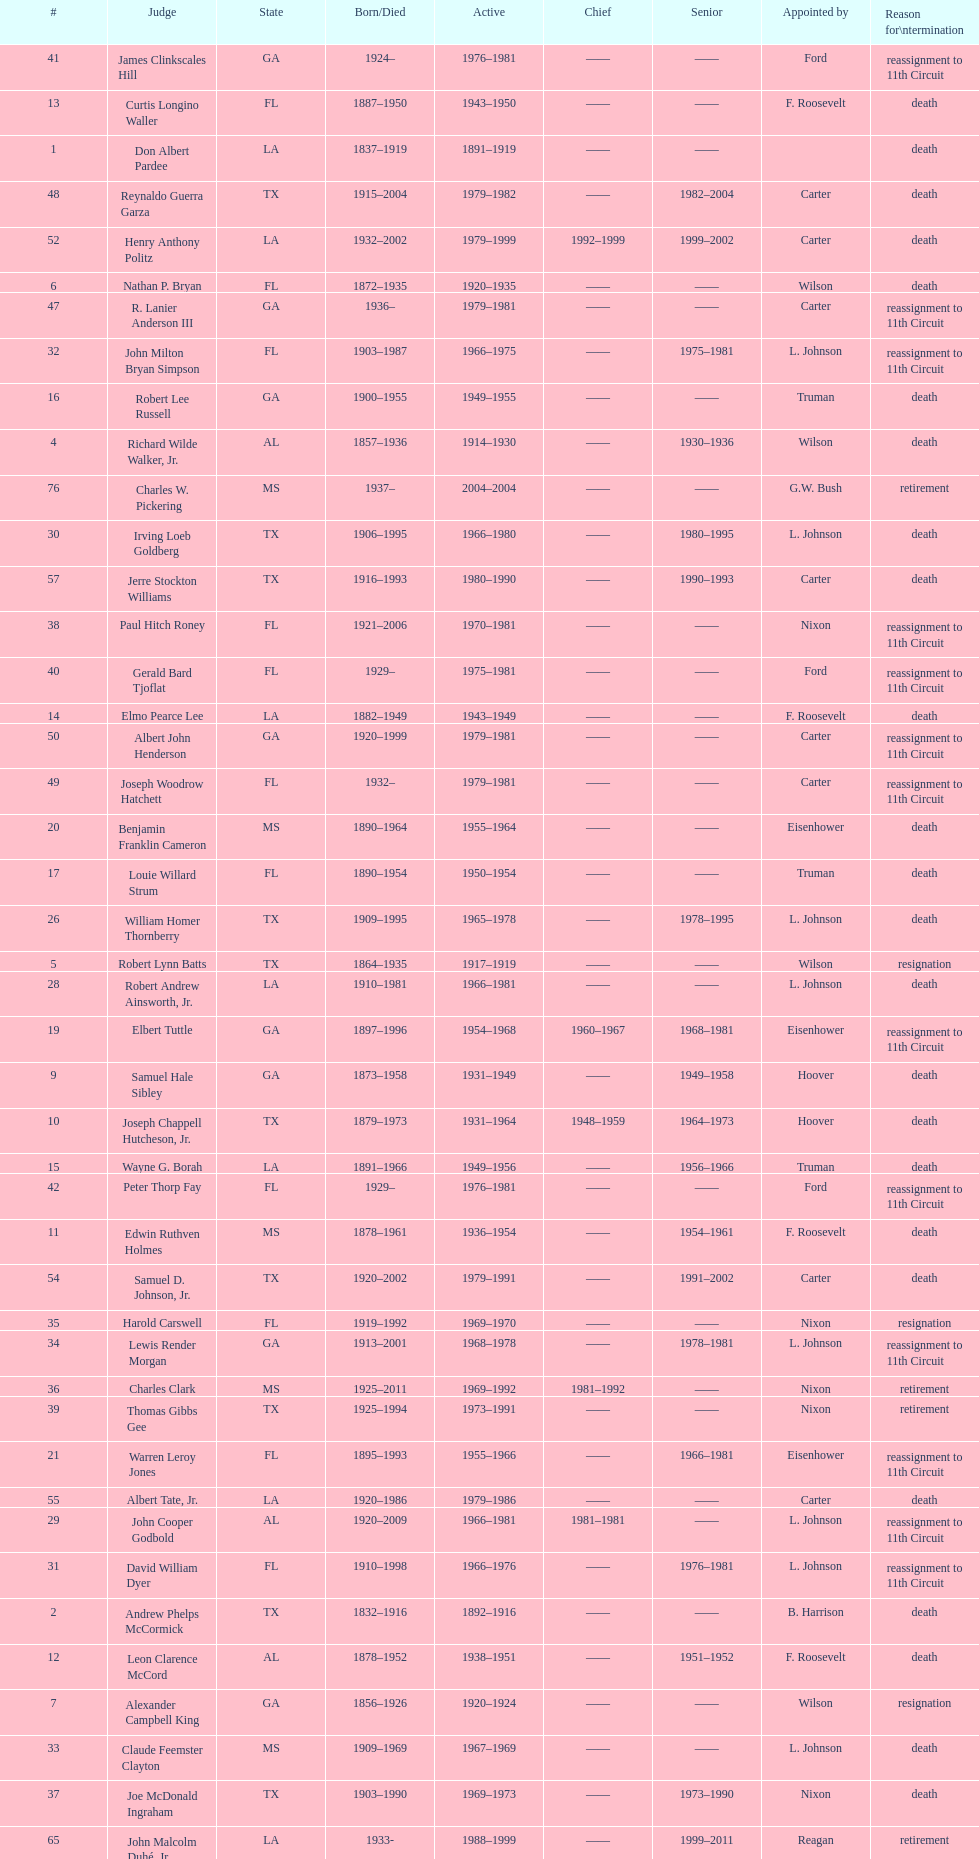How many judges were appointed by president carter? 13. Help me parse the entirety of this table. {'header': ['#', 'Judge', 'State', 'Born/Died', 'Active', 'Chief', 'Senior', 'Appointed by', 'Reason for\\ntermination'], 'rows': [['41', 'James Clinkscales Hill', 'GA', '1924–', '1976–1981', '——', '——', 'Ford', 'reassignment to 11th Circuit'], ['13', 'Curtis Longino Waller', 'FL', '1887–1950', '1943–1950', '——', '——', 'F. Roosevelt', 'death'], ['1', 'Don Albert Pardee', 'LA', '1837–1919', '1891–1919', '——', '——', '', 'death'], ['48', 'Reynaldo Guerra Garza', 'TX', '1915–2004', '1979–1982', '——', '1982–2004', 'Carter', 'death'], ['52', 'Henry Anthony Politz', 'LA', '1932–2002', '1979–1999', '1992–1999', '1999–2002', 'Carter', 'death'], ['6', 'Nathan P. Bryan', 'FL', '1872–1935', '1920–1935', '——', '——', 'Wilson', 'death'], ['47', 'R. Lanier Anderson III', 'GA', '1936–', '1979–1981', '——', '——', 'Carter', 'reassignment to 11th Circuit'], ['32', 'John Milton Bryan Simpson', 'FL', '1903–1987', '1966–1975', '——', '1975–1981', 'L. Johnson', 'reassignment to 11th Circuit'], ['16', 'Robert Lee Russell', 'GA', '1900–1955', '1949–1955', '——', '——', 'Truman', 'death'], ['4', 'Richard Wilde Walker, Jr.', 'AL', '1857–1936', '1914–1930', '——', '1930–1936', 'Wilson', 'death'], ['76', 'Charles W. Pickering', 'MS', '1937–', '2004–2004', '——', '——', 'G.W. Bush', 'retirement'], ['30', 'Irving Loeb Goldberg', 'TX', '1906–1995', '1966–1980', '——', '1980–1995', 'L. Johnson', 'death'], ['57', 'Jerre Stockton Williams', 'TX', '1916–1993', '1980–1990', '——', '1990–1993', 'Carter', 'death'], ['38', 'Paul Hitch Roney', 'FL', '1921–2006', '1970–1981', '——', '——', 'Nixon', 'reassignment to 11th Circuit'], ['40', 'Gerald Bard Tjoflat', 'FL', '1929–', '1975–1981', '——', '——', 'Ford', 'reassignment to 11th Circuit'], ['14', 'Elmo Pearce Lee', 'LA', '1882–1949', '1943–1949', '——', '——', 'F. Roosevelt', 'death'], ['50', 'Albert John Henderson', 'GA', '1920–1999', '1979–1981', '——', '——', 'Carter', 'reassignment to 11th Circuit'], ['49', 'Joseph Woodrow Hatchett', 'FL', '1932–', '1979–1981', '——', '——', 'Carter', 'reassignment to 11th Circuit'], ['20', 'Benjamin Franklin Cameron', 'MS', '1890–1964', '1955–1964', '——', '——', 'Eisenhower', 'death'], ['17', 'Louie Willard Strum', 'FL', '1890–1954', '1950–1954', '——', '——', 'Truman', 'death'], ['26', 'William Homer Thornberry', 'TX', '1909–1995', '1965–1978', '——', '1978–1995', 'L. Johnson', 'death'], ['5', 'Robert Lynn Batts', 'TX', '1864–1935', '1917–1919', '——', '——', 'Wilson', 'resignation'], ['28', 'Robert Andrew Ainsworth, Jr.', 'LA', '1910–1981', '1966–1981', '——', '——', 'L. Johnson', 'death'], ['19', 'Elbert Tuttle', 'GA', '1897–1996', '1954–1968', '1960–1967', '1968–1981', 'Eisenhower', 'reassignment to 11th Circuit'], ['9', 'Samuel Hale Sibley', 'GA', '1873–1958', '1931–1949', '——', '1949–1958', 'Hoover', 'death'], ['10', 'Joseph Chappell Hutcheson, Jr.', 'TX', '1879–1973', '1931–1964', '1948–1959', '1964–1973', 'Hoover', 'death'], ['15', 'Wayne G. Borah', 'LA', '1891–1966', '1949–1956', '——', '1956–1966', 'Truman', 'death'], ['42', 'Peter Thorp Fay', 'FL', '1929–', '1976–1981', '——', '——', 'Ford', 'reassignment to 11th Circuit'], ['11', 'Edwin Ruthven Holmes', 'MS', '1878–1961', '1936–1954', '——', '1954–1961', 'F. Roosevelt', 'death'], ['54', 'Samuel D. Johnson, Jr.', 'TX', '1920–2002', '1979–1991', '——', '1991–2002', 'Carter', 'death'], ['35', 'Harold Carswell', 'FL', '1919–1992', '1969–1970', '——', '——', 'Nixon', 'resignation'], ['34', 'Lewis Render Morgan', 'GA', '1913–2001', '1968–1978', '——', '1978–1981', 'L. Johnson', 'reassignment to 11th Circuit'], ['36', 'Charles Clark', 'MS', '1925–2011', '1969–1992', '1981–1992', '——', 'Nixon', 'retirement'], ['39', 'Thomas Gibbs Gee', 'TX', '1925–1994', '1973–1991', '——', '——', 'Nixon', 'retirement'], ['21', 'Warren Leroy Jones', 'FL', '1895–1993', '1955–1966', '——', '1966–1981', 'Eisenhower', 'reassignment to 11th Circuit'], ['55', 'Albert Tate, Jr.', 'LA', '1920–1986', '1979–1986', '——', '——', 'Carter', 'death'], ['29', 'John Cooper Godbold', 'AL', '1920–2009', '1966–1981', '1981–1981', '——', 'L. Johnson', 'reassignment to 11th Circuit'], ['31', 'David William Dyer', 'FL', '1910–1998', '1966–1976', '——', '1976–1981', 'L. Johnson', 'reassignment to 11th Circuit'], ['2', 'Andrew Phelps McCormick', 'TX', '1832–1916', '1892–1916', '——', '——', 'B. Harrison', 'death'], ['12', 'Leon Clarence McCord', 'AL', '1878–1952', '1938–1951', '——', '1951–1952', 'F. Roosevelt', 'death'], ['7', 'Alexander Campbell King', 'GA', '1856–1926', '1920–1924', '——', '——', 'Wilson', 'resignation'], ['33', 'Claude Feemster Clayton', 'MS', '1909–1969', '1967–1969', '——', '——', 'L. Johnson', 'death'], ['37', 'Joe McDonald Ingraham', 'TX', '1903–1990', '1969–1973', '——', '1973–1990', 'Nixon', 'death'], ['65', 'John Malcolm Duhé, Jr.', 'LA', '1933-', '1988–1999', '——', '1999–2011', 'Reagan', 'retirement'], ['72', 'Robert Manley Parker', 'TX', '1937–', '1994–2002', '——', '——', 'Clinton', 'retirement'], ['25', 'Walter Pettus Gewin', 'AL', '1908–1981', '1961–1976', '——', '1976–1981', 'Kennedy', 'death'], ['58', 'William Lockhart Garwood', 'TX', '1931–2011', '1981–1997', '——', '1997–2011', 'Reagan', 'death'], ['46', 'Frank Minis Johnson', 'AL', '1918–1999', '1979–1981', '——', '——', 'Carter', 'reassignment to 11th Circuit'], ['3', 'David Davie Shelby', 'AL', '1847–1914', '1899–1914', '——', '——', 'McKinley', 'death'], ['18', 'Richard Rives', 'AL', '1895–1982', '1951–1966', '1959–1960', '1966–1981', 'Truman', 'reassignment to 11th Circuit'], ['43', 'Alvin Benjamin Rubin', 'LA', '1920–1991', '1977–1989', '——', '1989–1991', 'Carter', 'death'], ['45', 'Phyllis A. Kravitch', 'GA', '1920–', '1979–1981', '——', '——', 'Carter', 'reassignment to 11th Circuit'], ['24', 'Griffin Bell', 'GA', '1918–2009', '1961–1976', '——', '——', 'Kennedy', 'resignation'], ['27', 'James Plemon Coleman', 'MS', '1914–1991', '1965–1981', '1979–1981', '1981–1984', 'L. Johnson', 'resignation'], ['23', 'John Minor Wisdom', 'LA', '1905–1999', '1957–1977', '——', '1977–1999', 'Eisenhower', 'death'], ['22', 'John Robert Brown', 'TX', '1909–1984', '1955–1984', '1967–1979', '1984–1993', 'Eisenhower', 'death'], ['62', 'Robert Madden Hill', 'TX', '1928–1987', '1984–1987', '——', '——', 'Reagan', 'death'], ['56', 'Thomas Alonzo Clark', 'GA', '1920–2005', '1979–1981', '——', '——', 'Carter', 'reassignment to 11th Circuit'], ['44', 'Robert Smith Vance', 'AL', '1931–1989', '1977–1981', '——', '——', 'Carter', 'reassignment to 11th Circuit'], ['8', 'Rufus Edward Foster', 'LA', '1871–1942', '1925–1942', '——', '——', 'Coolidge', 'death']]} 